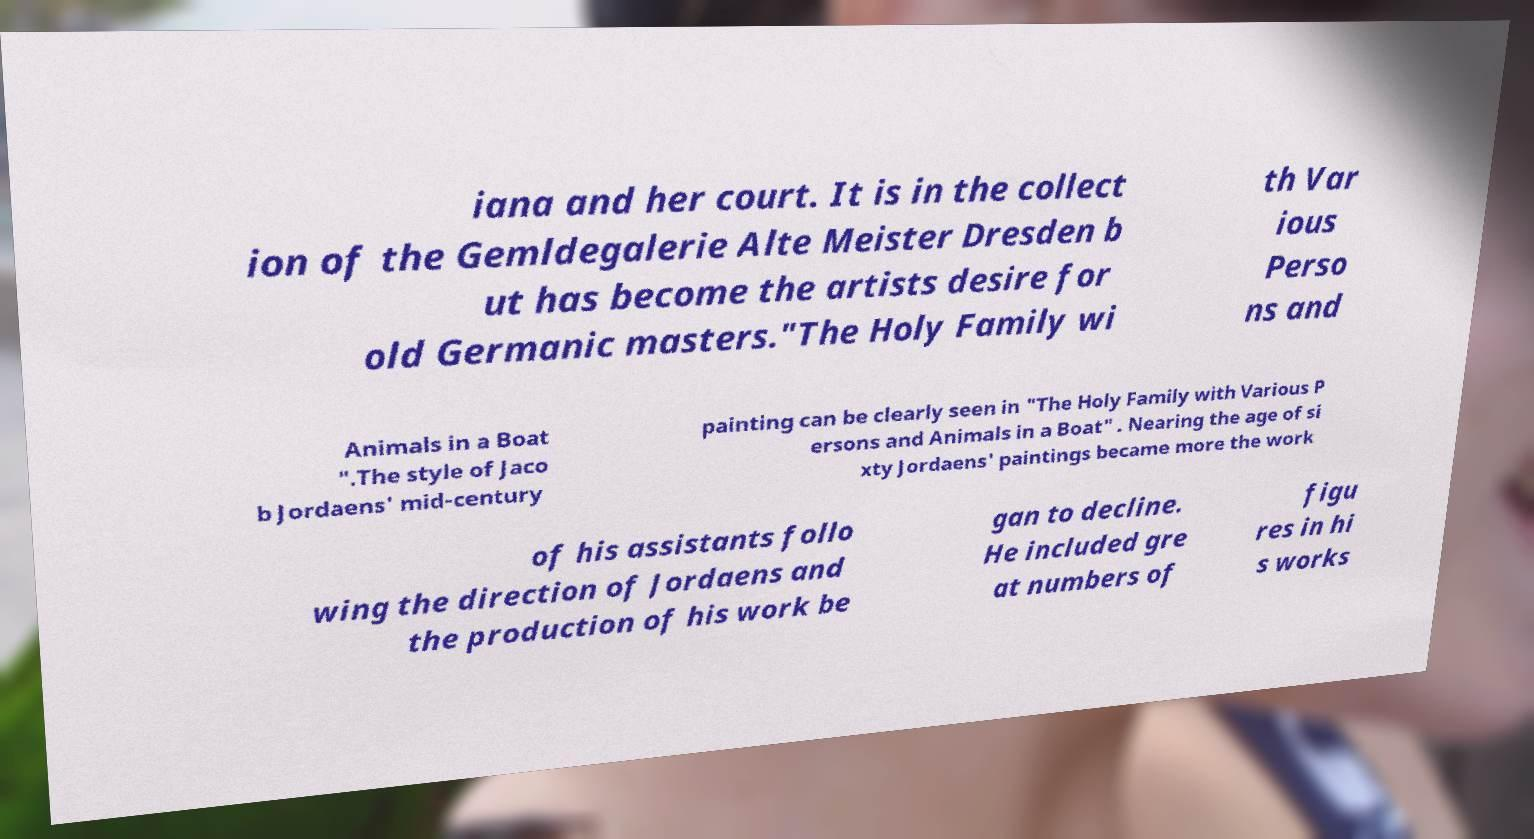There's text embedded in this image that I need extracted. Can you transcribe it verbatim? iana and her court. It is in the collect ion of the Gemldegalerie Alte Meister Dresden b ut has become the artists desire for old Germanic masters."The Holy Family wi th Var ious Perso ns and Animals in a Boat ".The style of Jaco b Jordaens' mid-century painting can be clearly seen in "The Holy Family with Various P ersons and Animals in a Boat" . Nearing the age of si xty Jordaens' paintings became more the work of his assistants follo wing the direction of Jordaens and the production of his work be gan to decline. He included gre at numbers of figu res in hi s works 